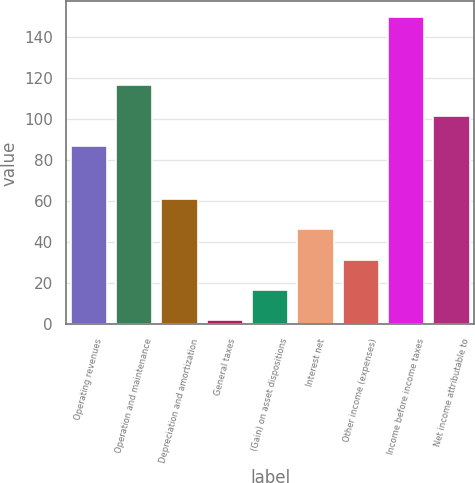<chart> <loc_0><loc_0><loc_500><loc_500><bar_chart><fcel>Operating revenues<fcel>Operation and maintenance<fcel>Depreciation and amortization<fcel>General taxes<fcel>(Gain) on asset dispositions<fcel>Interest net<fcel>Other income (expenses)<fcel>Income before income taxes<fcel>Net income attributable to<nl><fcel>87<fcel>116.6<fcel>61.2<fcel>2<fcel>16.8<fcel>46.4<fcel>31.6<fcel>150<fcel>101.8<nl></chart> 